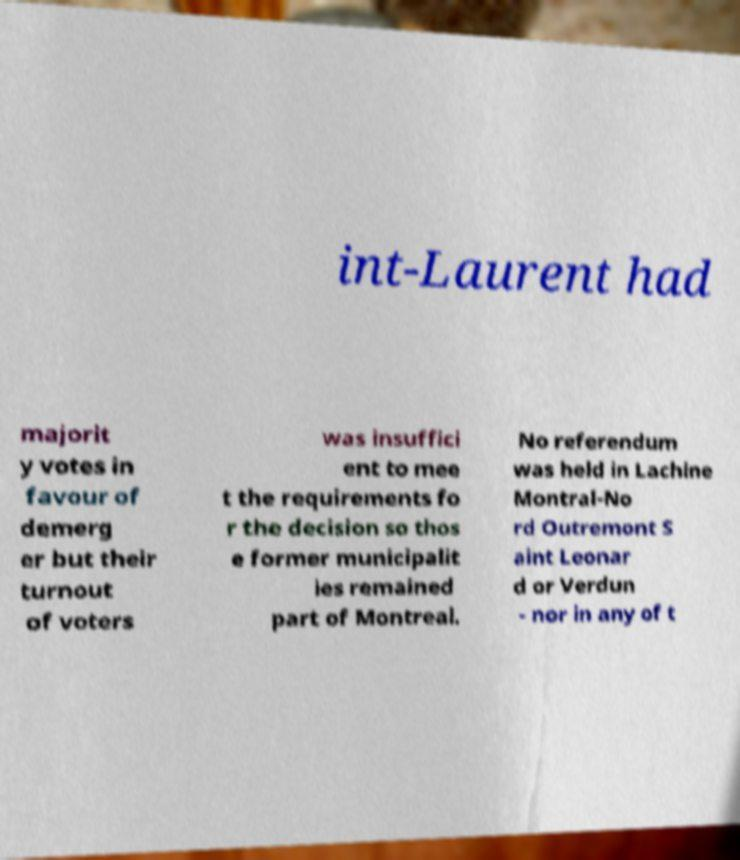Can you read and provide the text displayed in the image?This photo seems to have some interesting text. Can you extract and type it out for me? int-Laurent had majorit y votes in favour of demerg er but their turnout of voters was insuffici ent to mee t the requirements fo r the decision so thos e former municipalit ies remained part of Montreal. No referendum was held in Lachine Montral-No rd Outremont S aint Leonar d or Verdun - nor in any of t 